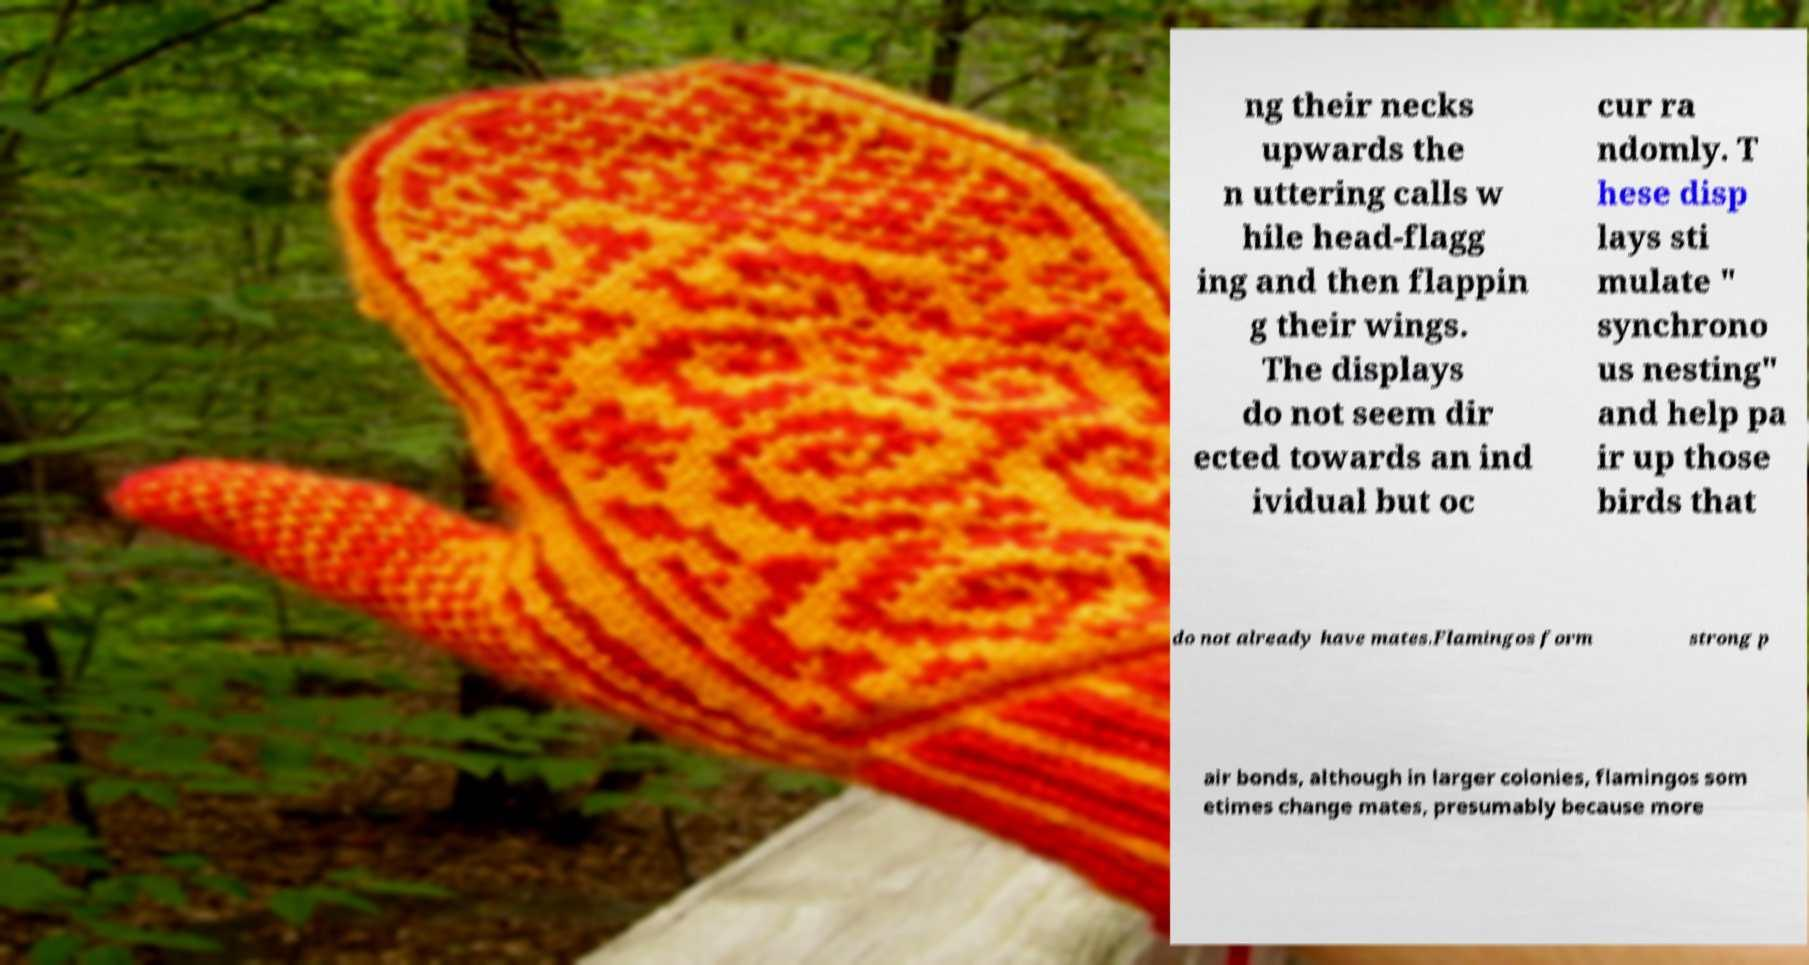I need the written content from this picture converted into text. Can you do that? ng their necks upwards the n uttering calls w hile head-flagg ing and then flappin g their wings. The displays do not seem dir ected towards an ind ividual but oc cur ra ndomly. T hese disp lays sti mulate " synchrono us nesting" and help pa ir up those birds that do not already have mates.Flamingos form strong p air bonds, although in larger colonies, flamingos som etimes change mates, presumably because more 